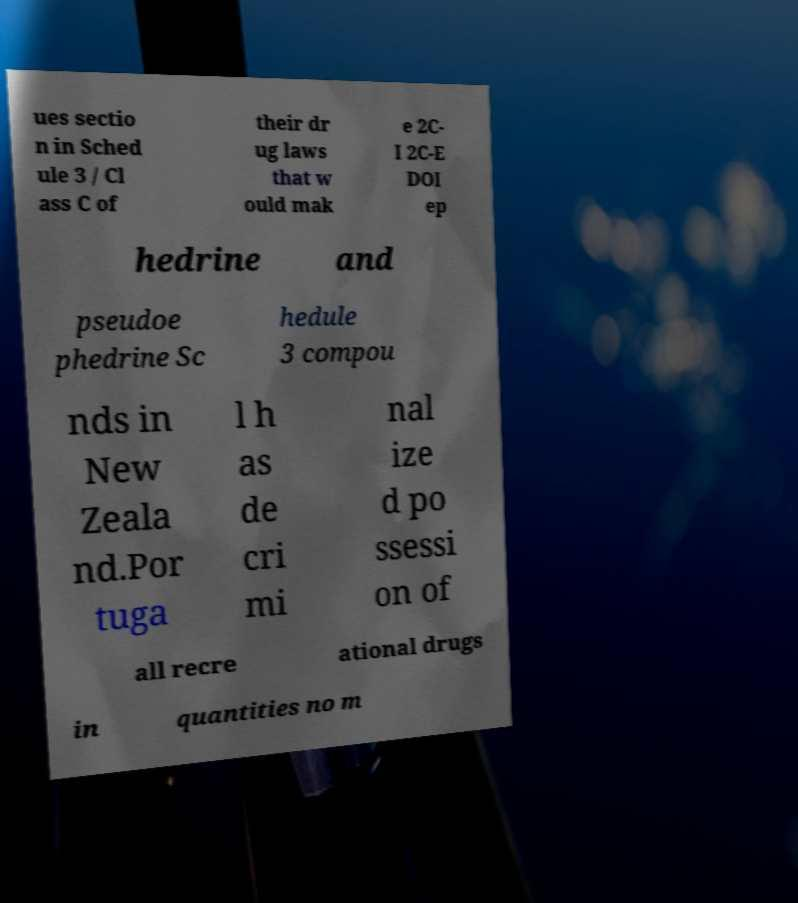Please identify and transcribe the text found in this image. ues sectio n in Sched ule 3 / Cl ass C of their dr ug laws that w ould mak e 2C- I 2C-E DOI ep hedrine and pseudoe phedrine Sc hedule 3 compou nds in New Zeala nd.Por tuga l h as de cri mi nal ize d po ssessi on of all recre ational drugs in quantities no m 